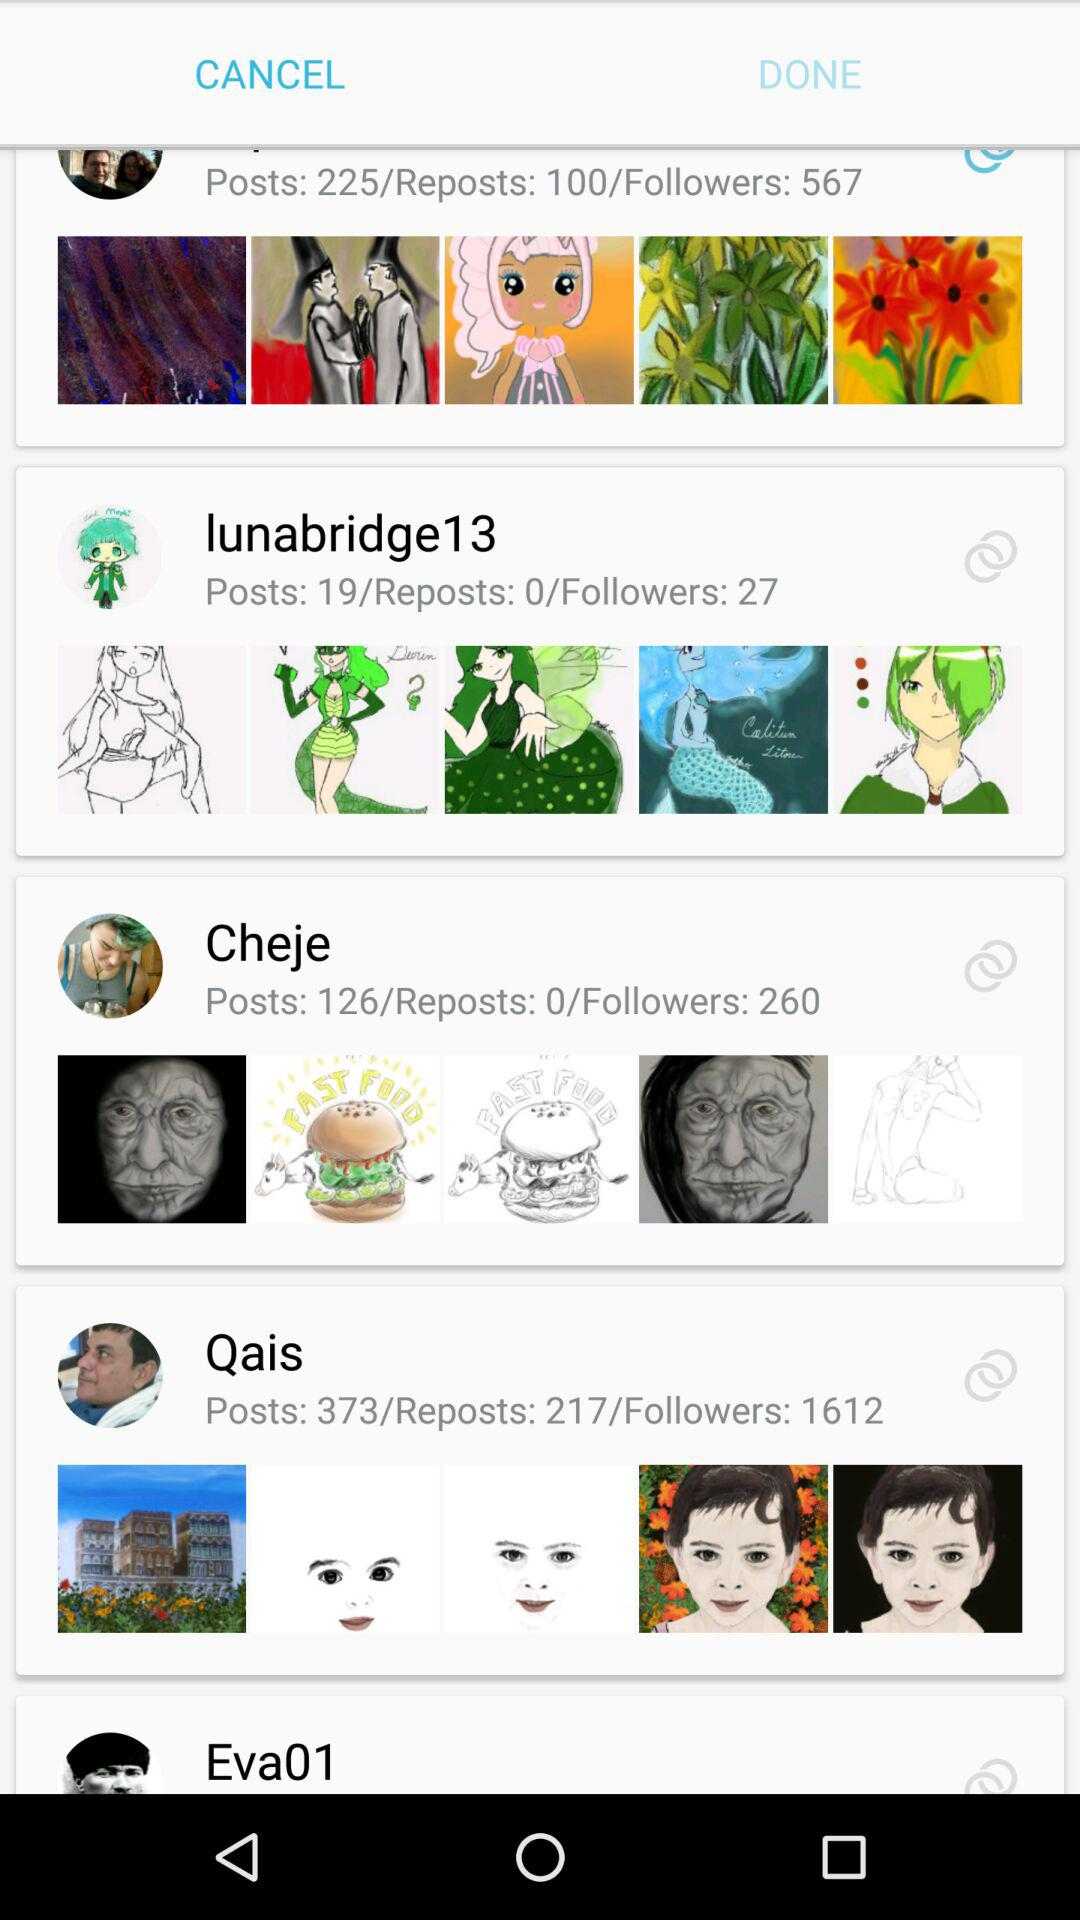How many followers of cheje? There are 260 followers. 